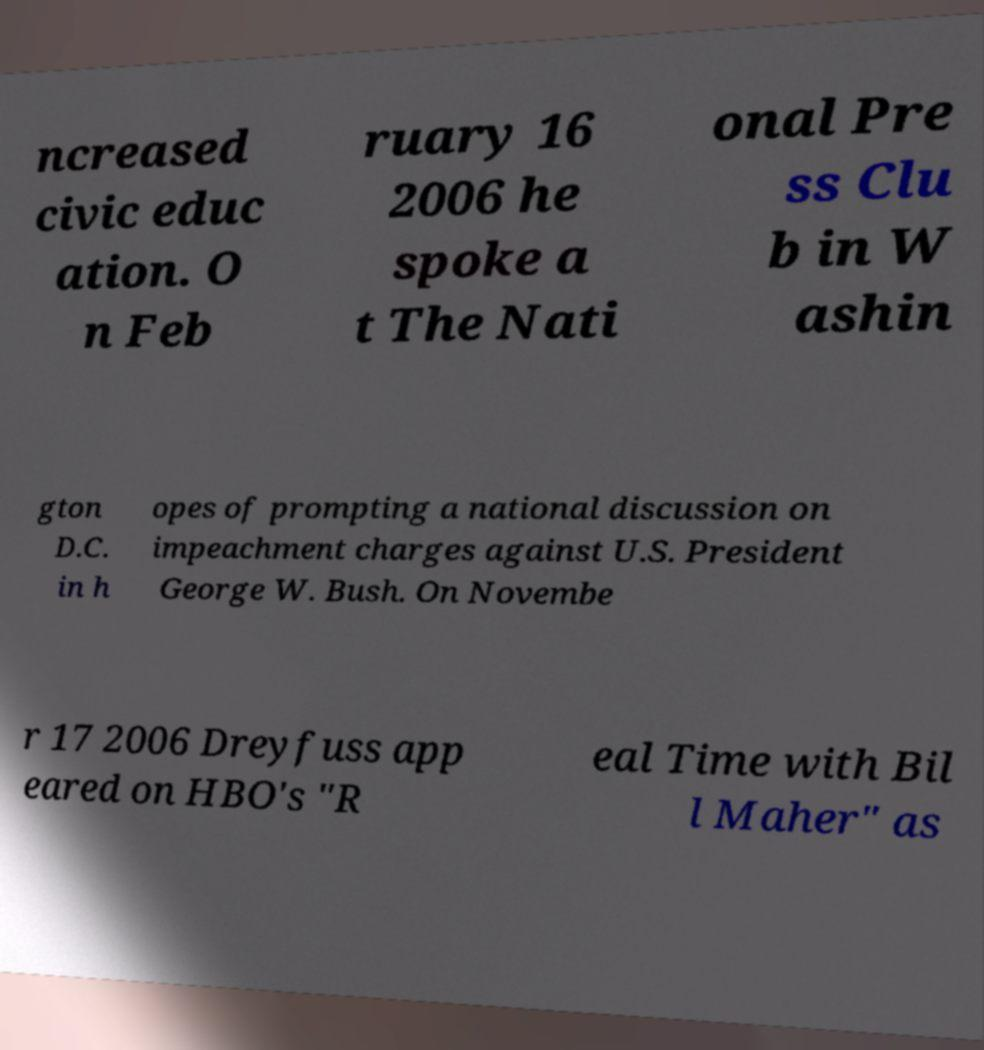Can you read and provide the text displayed in the image?This photo seems to have some interesting text. Can you extract and type it out for me? ncreased civic educ ation. O n Feb ruary 16 2006 he spoke a t The Nati onal Pre ss Clu b in W ashin gton D.C. in h opes of prompting a national discussion on impeachment charges against U.S. President George W. Bush. On Novembe r 17 2006 Dreyfuss app eared on HBO's "R eal Time with Bil l Maher" as 